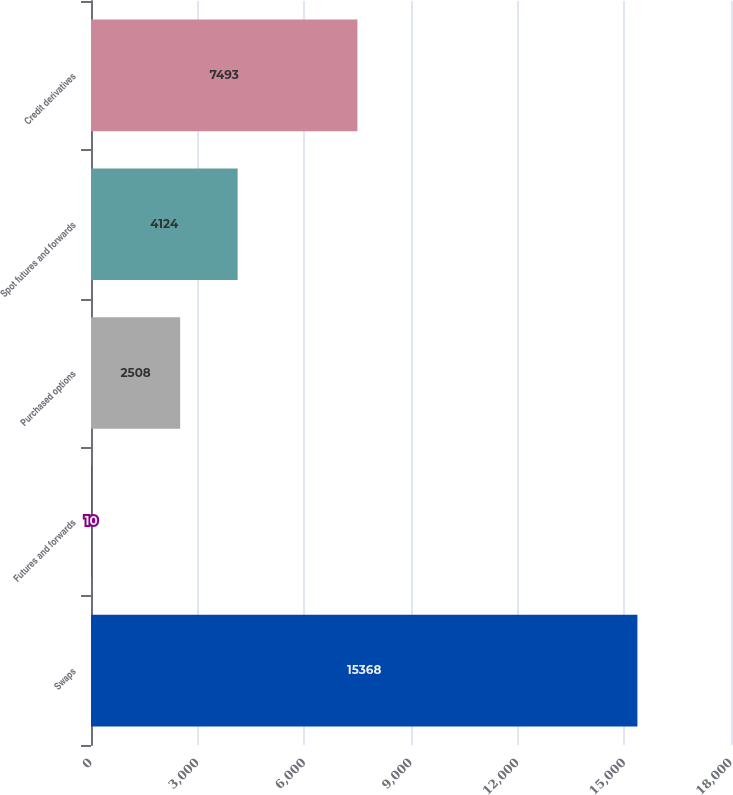<chart> <loc_0><loc_0><loc_500><loc_500><bar_chart><fcel>Swaps<fcel>Futures and forwards<fcel>Purchased options<fcel>Spot futures and forwards<fcel>Credit derivatives<nl><fcel>15368<fcel>10<fcel>2508<fcel>4124<fcel>7493<nl></chart> 